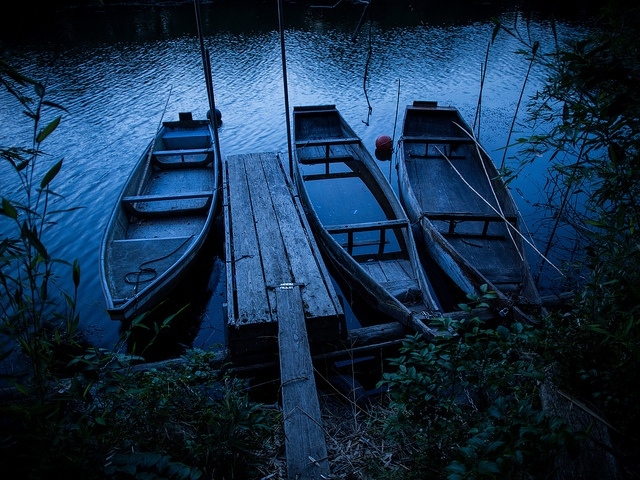Describe the objects in this image and their specific colors. I can see boat in black, navy, darkblue, and blue tones, boat in black, blue, navy, and darkblue tones, and boat in black, blue, navy, and darkblue tones in this image. 